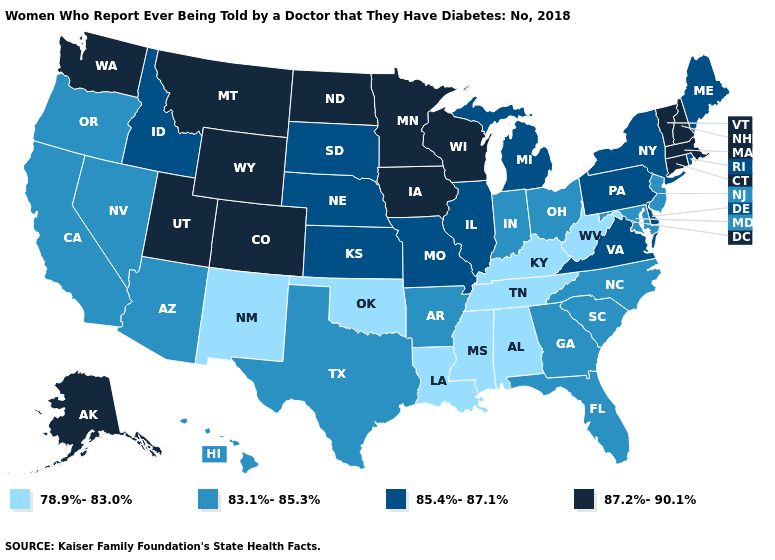What is the value of Wisconsin?
Short answer required. 87.2%-90.1%. Which states have the highest value in the USA?
Write a very short answer. Alaska, Colorado, Connecticut, Iowa, Massachusetts, Minnesota, Montana, New Hampshire, North Dakota, Utah, Vermont, Washington, Wisconsin, Wyoming. Which states hav the highest value in the MidWest?
Short answer required. Iowa, Minnesota, North Dakota, Wisconsin. Does the first symbol in the legend represent the smallest category?
Concise answer only. Yes. Is the legend a continuous bar?
Concise answer only. No. Does the first symbol in the legend represent the smallest category?
Answer briefly. Yes. Does the map have missing data?
Keep it brief. No. What is the value of Maryland?
Write a very short answer. 83.1%-85.3%. Which states have the lowest value in the Northeast?
Be succinct. New Jersey. Which states have the lowest value in the West?
Quick response, please. New Mexico. What is the lowest value in states that border Rhode Island?
Keep it brief. 87.2%-90.1%. What is the value of Wyoming?
Concise answer only. 87.2%-90.1%. Name the states that have a value in the range 83.1%-85.3%?
Answer briefly. Arizona, Arkansas, California, Florida, Georgia, Hawaii, Indiana, Maryland, Nevada, New Jersey, North Carolina, Ohio, Oregon, South Carolina, Texas. What is the lowest value in the MidWest?
Write a very short answer. 83.1%-85.3%. 